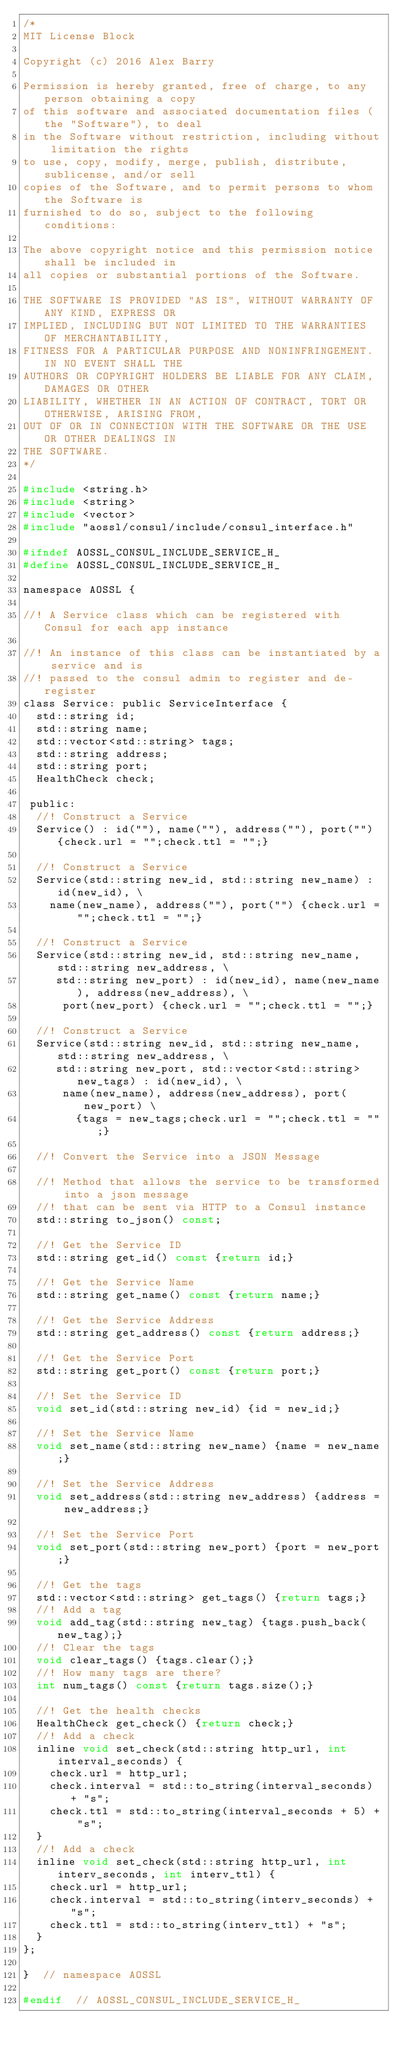Convert code to text. <code><loc_0><loc_0><loc_500><loc_500><_C_>/*
MIT License Block

Copyright (c) 2016 Alex Barry

Permission is hereby granted, free of charge, to any person obtaining a copy
of this software and associated documentation files (the "Software"), to deal
in the Software without restriction, including without limitation the rights
to use, copy, modify, merge, publish, distribute, sublicense, and/or sell
copies of the Software, and to permit persons to whom the Software is
furnished to do so, subject to the following conditions:

The above copyright notice and this permission notice shall be included in
all copies or substantial portions of the Software.

THE SOFTWARE IS PROVIDED "AS IS", WITHOUT WARRANTY OF ANY KIND, EXPRESS OR
IMPLIED, INCLUDING BUT NOT LIMITED TO THE WARRANTIES OF MERCHANTABILITY,
FITNESS FOR A PARTICULAR PURPOSE AND NONINFRINGEMENT. IN NO EVENT SHALL THE
AUTHORS OR COPYRIGHT HOLDERS BE LIABLE FOR ANY CLAIM, DAMAGES OR OTHER
LIABILITY, WHETHER IN AN ACTION OF CONTRACT, TORT OR OTHERWISE, ARISING FROM,
OUT OF OR IN CONNECTION WITH THE SOFTWARE OR THE USE OR OTHER DEALINGS IN
THE SOFTWARE.
*/

#include <string.h>
#include <string>
#include <vector>
#include "aossl/consul/include/consul_interface.h"

#ifndef AOSSL_CONSUL_INCLUDE_SERVICE_H_
#define AOSSL_CONSUL_INCLUDE_SERVICE_H_

namespace AOSSL {

//! A Service class which can be registered with Consul for each app instance

//! An instance of this class can be instantiated by a service and is
//! passed to the consul admin to register and de-register
class Service: public ServiceInterface {
  std::string id;
  std::string name;
  std::vector<std::string> tags;
  std::string address;
  std::string port;
  HealthCheck check;

 public:
  //! Construct a Service
  Service() : id(""), name(""), address(""), port("") {check.url = "";check.ttl = "";}

  //! Construct a Service
  Service(std::string new_id, std::string new_name) : id(new_id), \
    name(new_name), address(""), port("") {check.url = "";check.ttl = "";}

  //! Construct a Service
  Service(std::string new_id, std::string new_name, std::string new_address, \
     std::string new_port) : id(new_id), name(new_name), address(new_address), \
      port(new_port) {check.url = "";check.ttl = "";}

  //! Construct a Service
  Service(std::string new_id, std::string new_name, std::string new_address, \
     std::string new_port, std::vector<std::string> new_tags) : id(new_id), \
      name(new_name), address(new_address), port(new_port) \
        {tags = new_tags;check.url = "";check.ttl = "";}

  //! Convert the Service into a JSON Message

  //! Method that allows the service to be transformed into a json message
  //! that can be sent via HTTP to a Consul instance
  std::string to_json() const;

  //! Get the Service ID
  std::string get_id() const {return id;}

  //! Get the Service Name
  std::string get_name() const {return name;}

  //! Get the Service Address
  std::string get_address() const {return address;}

  //! Get the Service Port
  std::string get_port() const {return port;}

  //! Set the Service ID
  void set_id(std::string new_id) {id = new_id;}

  //! Set the Service Name
  void set_name(std::string new_name) {name = new_name;}

  //! Set the Service Address
  void set_address(std::string new_address) {address = new_address;}

  //! Set the Service Port
  void set_port(std::string new_port) {port = new_port;}

  //! Get the tags
  std::vector<std::string> get_tags() {return tags;}
  //! Add a tag
  void add_tag(std::string new_tag) {tags.push_back(new_tag);}
  //! Clear the tags
  void clear_tags() {tags.clear();}
  //! How many tags are there?
  int num_tags() const {return tags.size();}

  //! Get the health checks
  HealthCheck get_check() {return check;}
  //! Add a check
  inline void set_check(std::string http_url, int interval_seconds) {
    check.url = http_url;
    check.interval = std::to_string(interval_seconds) + "s";
    check.ttl = std::to_string(interval_seconds + 5) + "s";
  }
  //! Add a check
  inline void set_check(std::string http_url, int interv_seconds, int interv_ttl) {
    check.url = http_url;
    check.interval = std::to_string(interv_seconds) + "s";
    check.ttl = std::to_string(interv_ttl) + "s";
  }
};

}  // namespace AOSSL

#endif  // AOSSL_CONSUL_INCLUDE_SERVICE_H_
</code> 